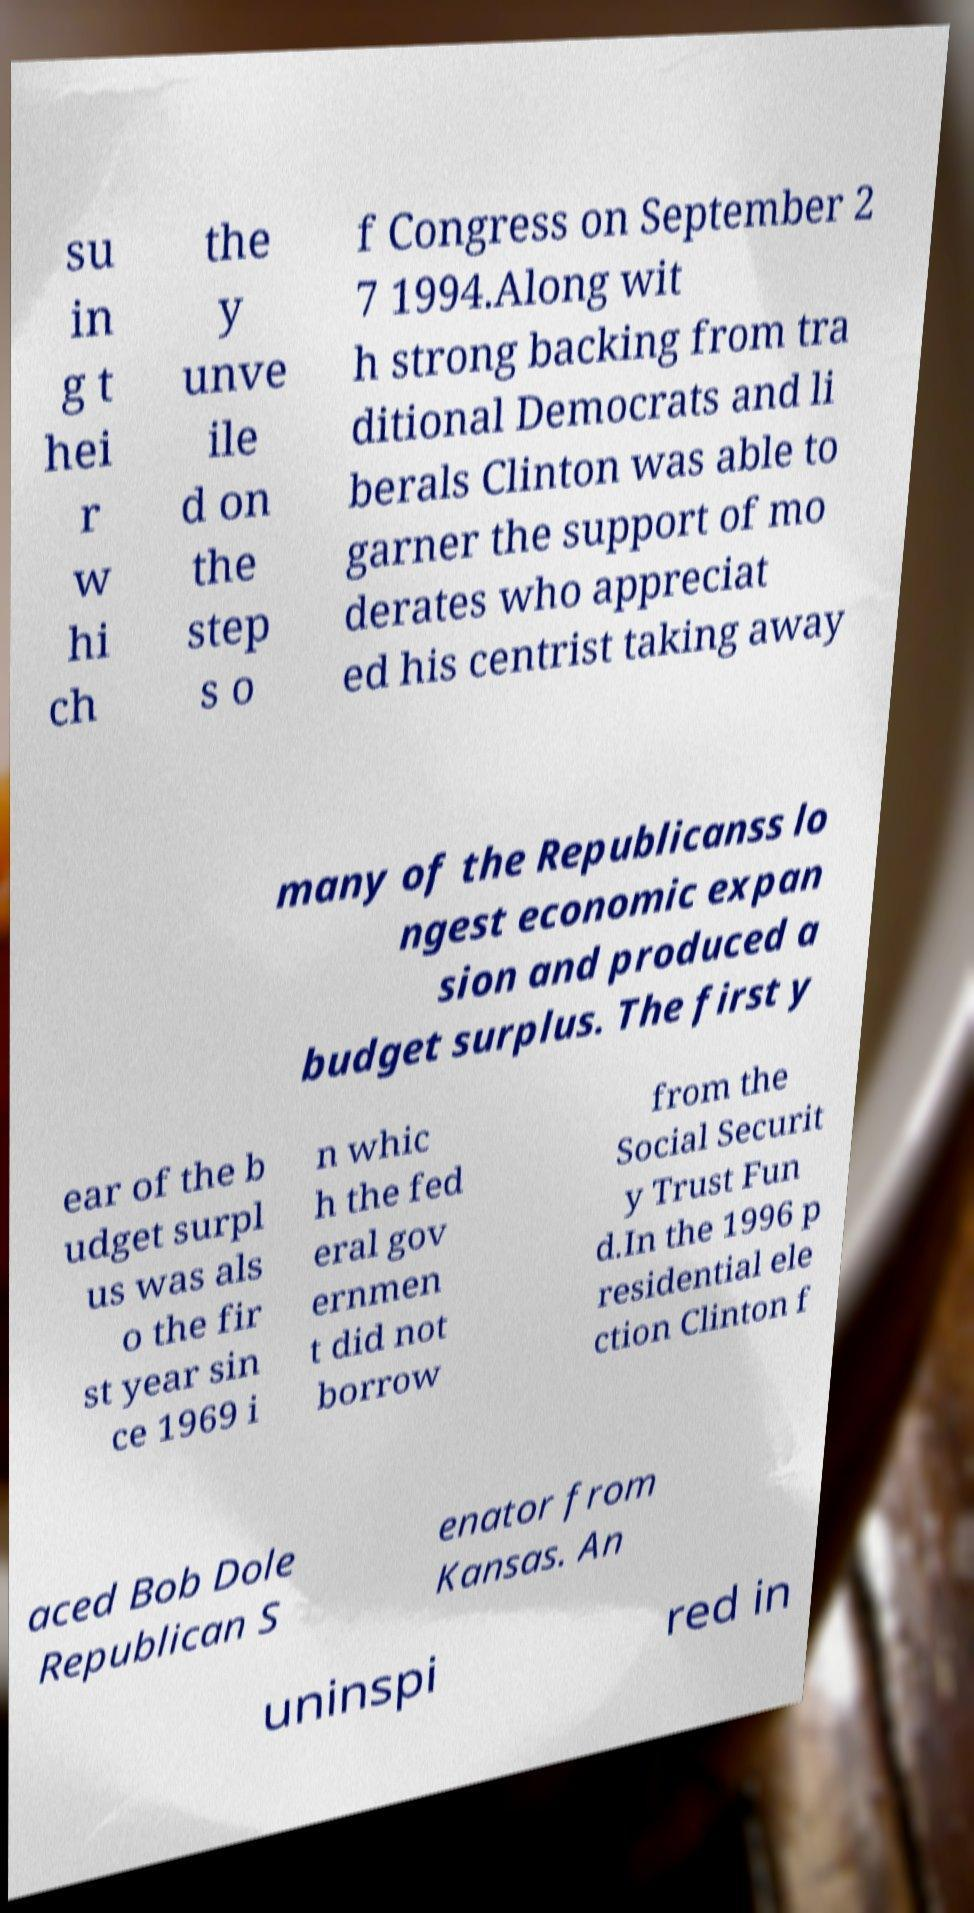What messages or text are displayed in this image? I need them in a readable, typed format. su in g t hei r w hi ch the y unve ile d on the step s o f Congress on September 2 7 1994.Along wit h strong backing from tra ditional Democrats and li berals Clinton was able to garner the support of mo derates who appreciat ed his centrist taking away many of the Republicanss lo ngest economic expan sion and produced a budget surplus. The first y ear of the b udget surpl us was als o the fir st year sin ce 1969 i n whic h the fed eral gov ernmen t did not borrow from the Social Securit y Trust Fun d.In the 1996 p residential ele ction Clinton f aced Bob Dole Republican S enator from Kansas. An uninspi red in 